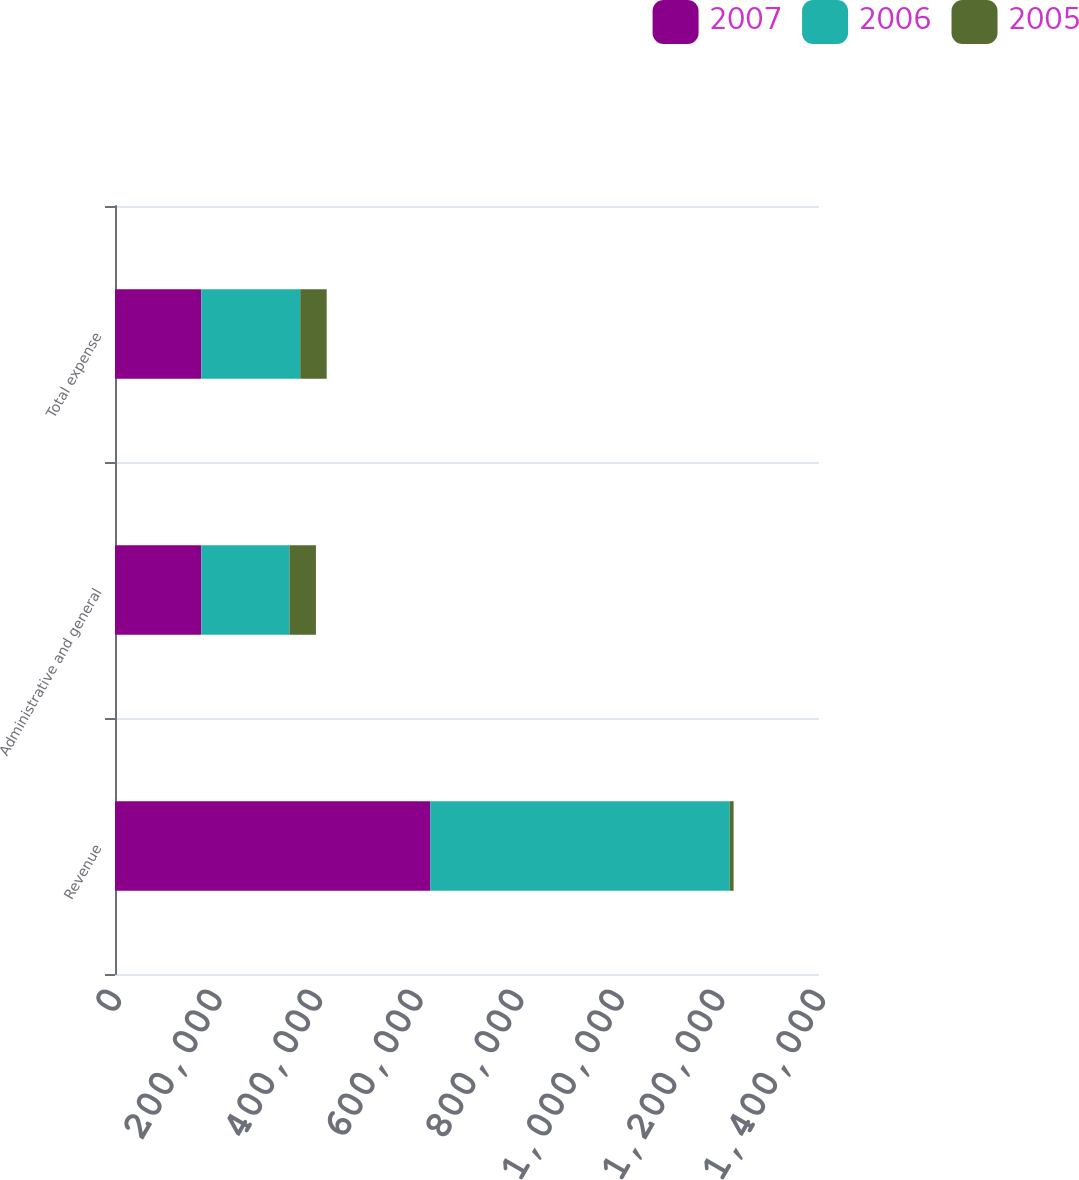Convert chart to OTSL. <chart><loc_0><loc_0><loc_500><loc_500><stacked_bar_chart><ecel><fcel>Revenue<fcel>Administrative and general<fcel>Total expense<nl><fcel>2007<fcel>626764<fcel>171741<fcel>171741<nl><fcel>2006<fcel>595702<fcel>175270<fcel>196642<nl><fcel>2005<fcel>7683<fcel>52579<fcel>52579<nl></chart> 